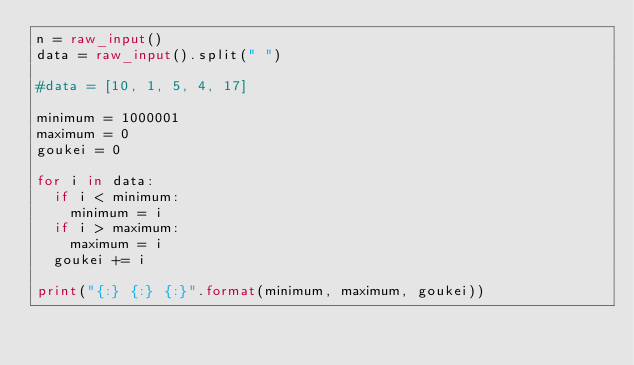<code> <loc_0><loc_0><loc_500><loc_500><_Python_>n = raw_input()
data = raw_input().split(" ")

#data = [10, 1, 5, 4, 17]

minimum = 1000001
maximum = 0
goukei = 0

for i in data:
	if i < minimum:
		minimum = i
	if i > maximum:
		maximum = i
	goukei += i

print("{:} {:} {:}".format(minimum, maximum, goukei))</code> 